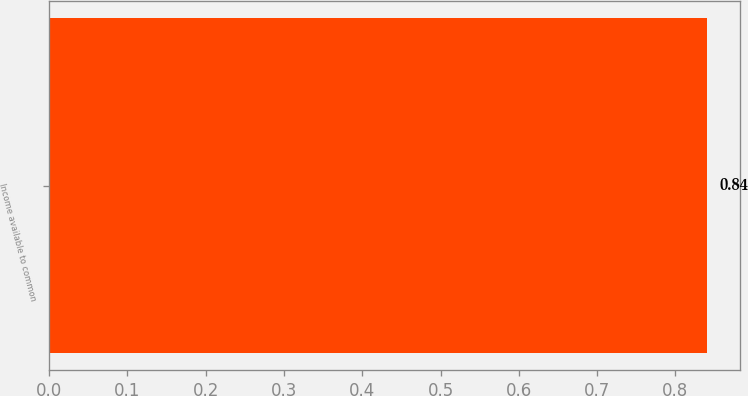Convert chart. <chart><loc_0><loc_0><loc_500><loc_500><bar_chart><fcel>Income available to common<nl><fcel>0.84<nl></chart> 